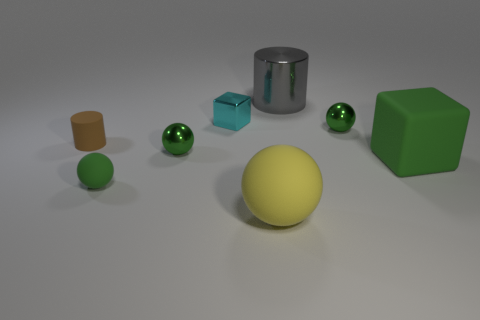There is a green rubber ball; how many metallic cubes are left of it?
Your answer should be compact. 0. Are there more tiny green shiny objects than yellow objects?
Ensure brevity in your answer.  Yes. What shape is the object that is on the left side of the large green cube and to the right of the large gray thing?
Your answer should be compact. Sphere. Is there a tiny cylinder?
Give a very brief answer. Yes. There is a small cyan object that is the same shape as the large green thing; what is it made of?
Make the answer very short. Metal. What is the shape of the green shiny thing that is behind the small rubber cylinder on the left side of the tiny sphere right of the gray metallic cylinder?
Offer a very short reply. Sphere. What material is the large cube that is the same color as the tiny rubber sphere?
Your response must be concise. Rubber. What number of tiny green shiny objects have the same shape as the large gray object?
Make the answer very short. 0. Is the color of the block that is in front of the cyan shiny thing the same as the tiny metallic ball to the right of the small cyan metal block?
Your answer should be very brief. Yes. What is the material of the gray cylinder that is the same size as the yellow object?
Your response must be concise. Metal. 